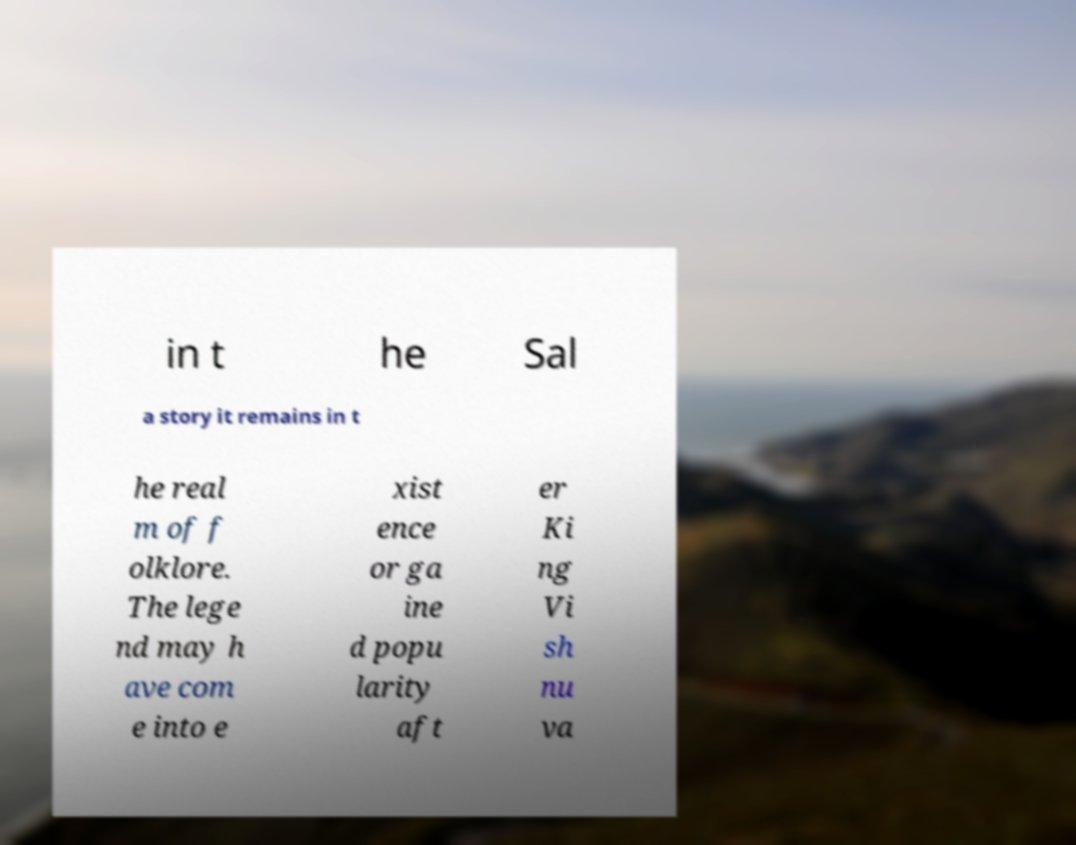Can you accurately transcribe the text from the provided image for me? in t he Sal a story it remains in t he real m of f olklore. The lege nd may h ave com e into e xist ence or ga ine d popu larity aft er Ki ng Vi sh nu va 